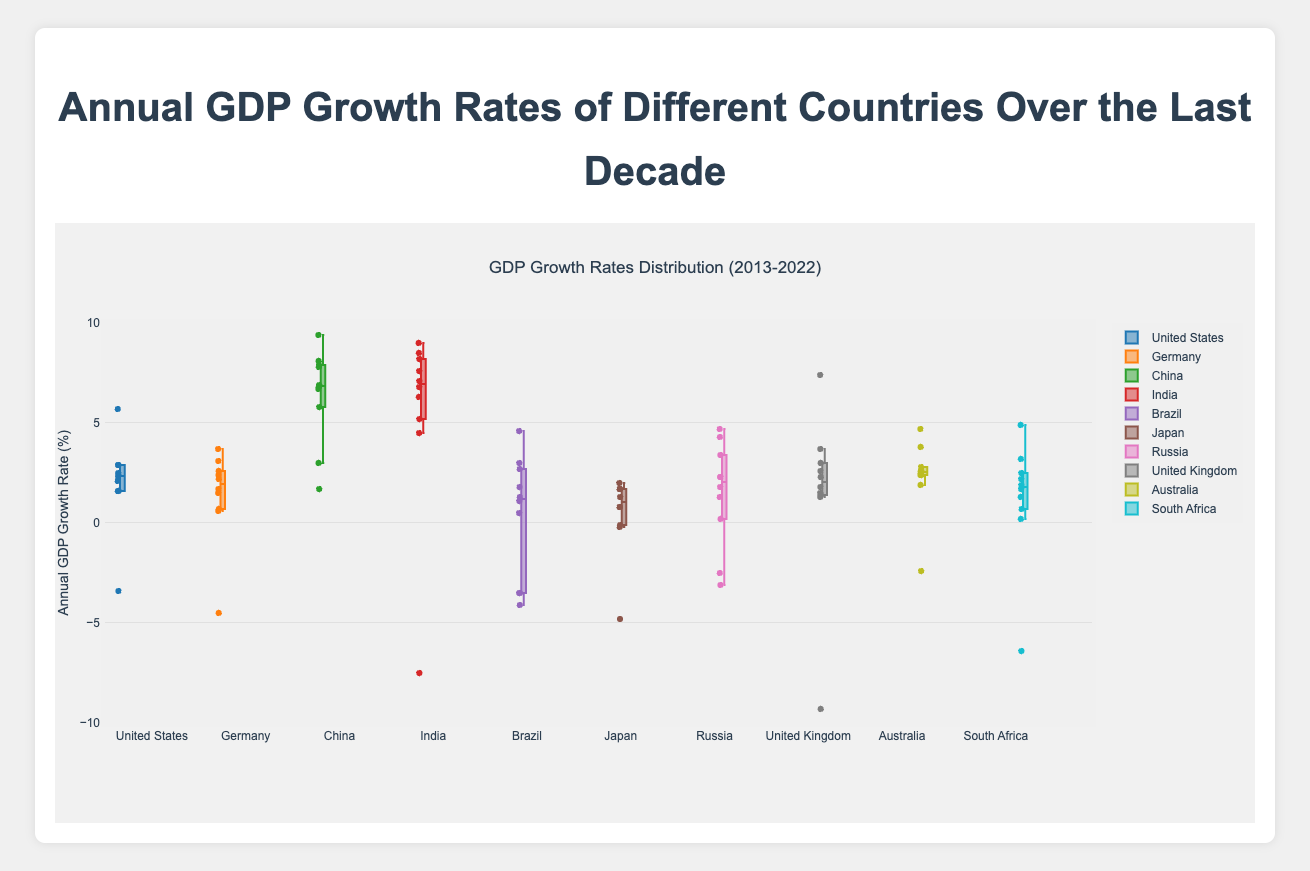What is the median GDP growth rate for China? The box plot for China shows a line inside the box that represents the median GDP growth rate.
Answer: 6.7% Which country had the most negative GDP growth rate, and what was the value? By looking at the lowest points in the box plots, the United Kingdom had the most negative GDP growth rate at -9.3%.
Answer: United Kingdom, -9.3% Which country has the highest median GDP growth rate over the last decade? The median is represented by the line inside each box. China has the highest median GDP growth rate.
Answer: China How does India’s range of GDP growth rates compare to Brazil’s? The range of GDP growth rates can be observed by looking at the spread of the whiskers in each box plot. India's range (-7.5% to 9%) is wider than Brazil's range (-4.1% to 4.6%).
Answer: India’s range is wider Which country has the smallest interquartile range (IQR) in GDP growth rates? The IQR is the length of the box in each plot, representing the middle 50% of the data. Australia has the smallest IQR.
Answer: Australia What are the lower and upper quartiles for Japan? The lower quartile is the bottom of the box and the upper quartile is the top of the box. For Japan, the lower quartile is approximately -0.2% and the upper quartile is around 1.7%.
Answer: -0.2%, 1.7% Which two countries have the most overlapping interquartile ranges? By comparing the boxes of the plots, the United States and Australia have the most overlapping interquartile ranges.
Answer: United States and Australia Compare the skewness of the GDP growth rates for Russia and South Africa. Skewness is visible through the position of the median line and the length of the whiskers. Russia appears to be fairly symmetrical, while South Africa is slightly negatively skewed.
Answer: Russia is symmetrical, South Africa is negatively skewed Which country's GDP growth rate had the maximum outlier, and what is the value? The outliers are represented by the points outside the whiskers. For China, one outlier reaches 9.4%, which is the maximum value.
Answer: China, 9.4% What was the approximate median GDP growth rate for the United Kingdom? The median GDP growth rate is marked by the line inside the box. For the United Kingdom, it is approximately 2.2%.
Answer: 2.2% 